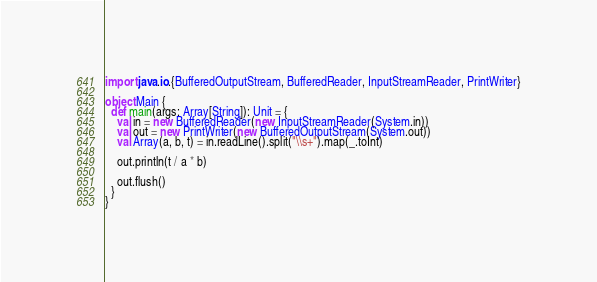Convert code to text. <code><loc_0><loc_0><loc_500><loc_500><_Scala_>import java.io.{BufferedOutputStream, BufferedReader, InputStreamReader, PrintWriter}

object Main {
  def main(args: Array[String]): Unit = {
    val in = new BufferedReader(new InputStreamReader(System.in))
    val out = new PrintWriter(new BufferedOutputStream(System.out))
    val Array(a, b, t) = in.readLine().split("\\s+").map(_.toInt)

    out.println(t / a * b)

    out.flush()
  }
}
</code> 